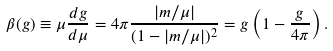Convert formula to latex. <formula><loc_0><loc_0><loc_500><loc_500>\beta ( g ) \equiv \mu \frac { d g } { d \mu } = 4 \pi \frac { | m / \mu | } { ( 1 - | m / \mu | ) ^ { 2 } } = g \left ( 1 - \frac { g } { 4 \pi } \right ) .</formula> 